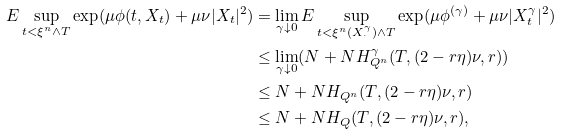<formula> <loc_0><loc_0><loc_500><loc_500>E \sup _ { t < \xi ^ { n } \wedge T } \exp ( \mu \phi ( t , X _ { t } ) + \mu \nu | X _ { t } | ^ { 2 } ) & = \lim _ { \gamma \downarrow 0 } E \sup _ { t < \xi ^ { n } ( X _ { \cdot } ^ { \gamma } ) \wedge T } \exp ( \mu \phi ^ { ( \gamma ) } + \mu \nu | X _ { t } ^ { \gamma } | ^ { 2 } ) \\ & \leq \lim _ { \gamma \downarrow 0 } ( N + N H _ { Q ^ { n } } ^ { \gamma } ( T , ( 2 - r \eta ) \nu , r ) ) \\ & \leq N + N H _ { Q ^ { n } } ( T , ( 2 - r \eta ) \nu , r ) \\ & \leq N + N H _ { Q } ( T , ( 2 - r \eta ) \nu , r ) ,</formula> 